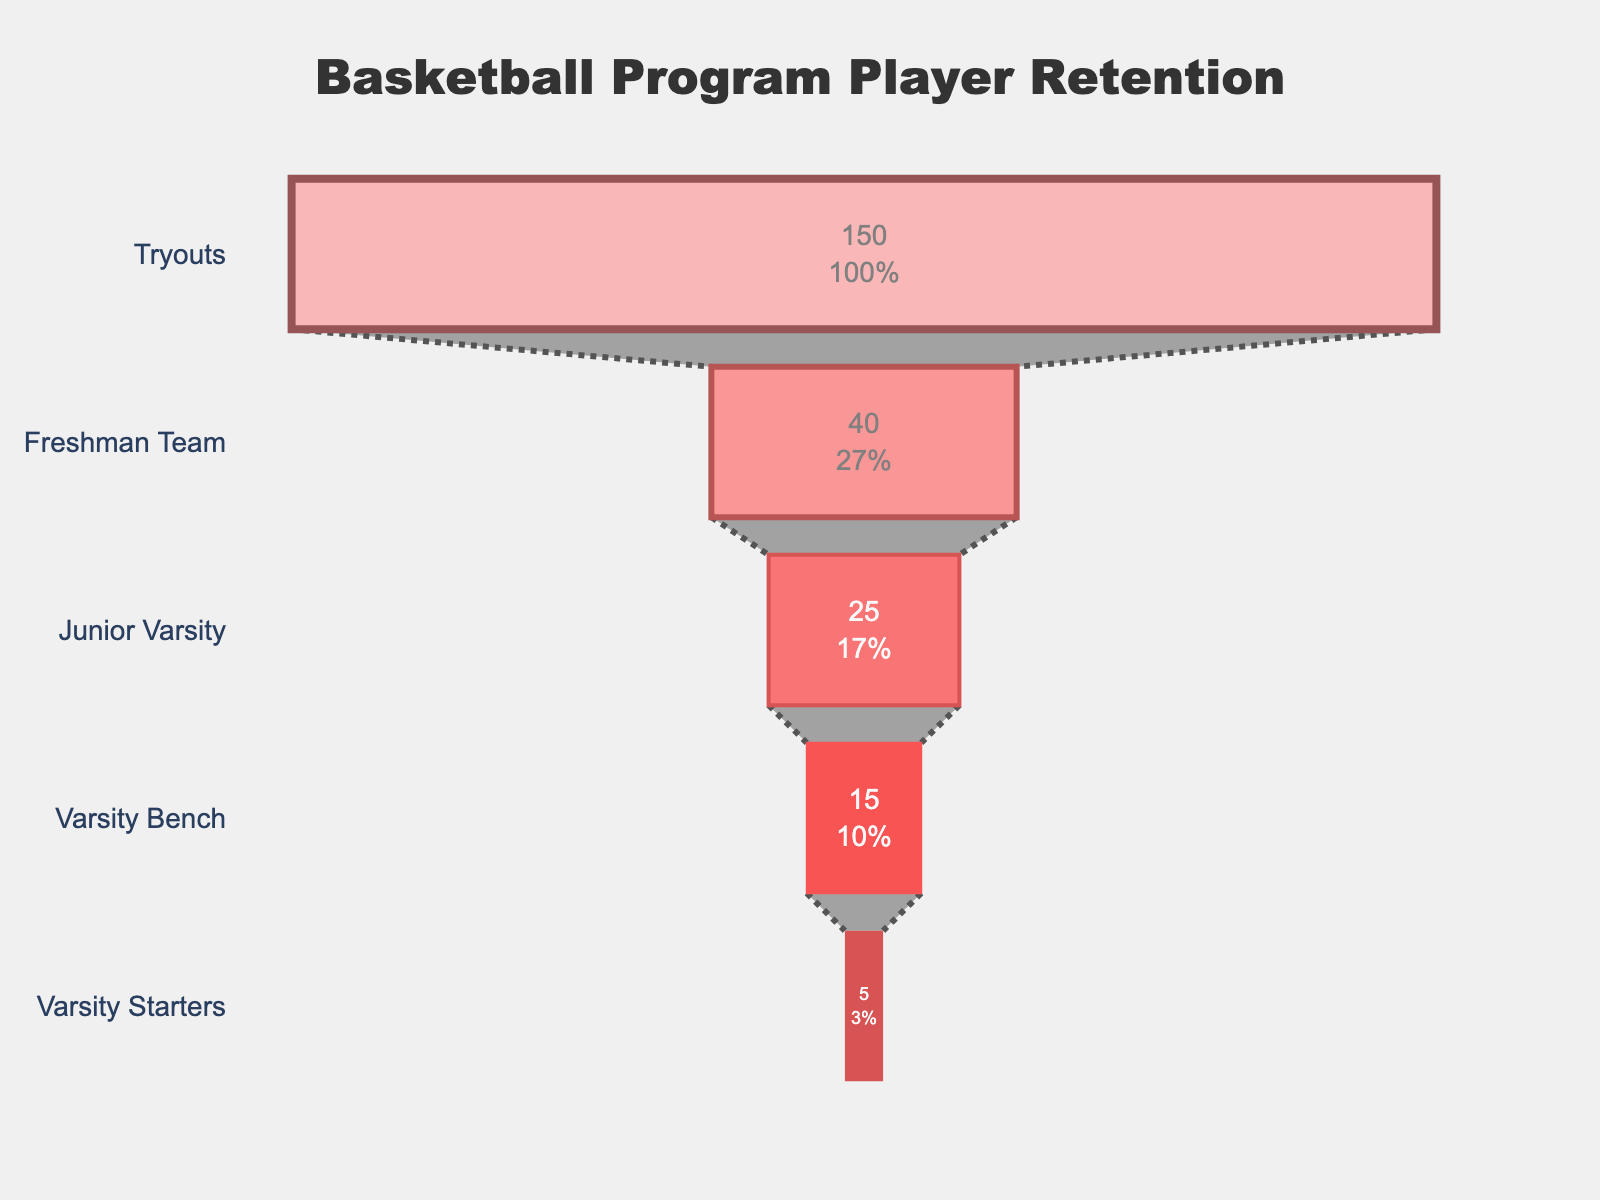What's the title of the chart? The title is usually displayed at the top of the chart. In this case, it states "Basketball Program Player Retention."
Answer: Basketball Program Player Retention How many players advanced to the Freshman Team stage? Each stage displays the number of players retained from the previous stage. For the Freshman Team, the figure shows 40 players.
Answer: 40 What percentage of players from tryouts make it to the varsity starters? The figure displays percentage values inside each section. To find the percentage from tryouts to varsity starters, divide 5 by 150 and multiply by 100. The figure shows this percentage as well.
Answer: 3.33% How many players drop out after the Freshman Team stage? The number of players at Freshman Team is 40 and at Junior Varsity is 25. The difference, 40 - 25, gives the number who drop out.
Answer: 15 Which stage has the steepest drop in player numbers? By comparing the differences between each consecutive stage, the largest decrease is from Tryouts (150) to Freshman Team (40). The difference is 110, making it the steepest drop.
Answer: Tryouts to Freshman Team How many players make it to the Varsity Starters stage? This number is displayed for the Varsity Starters directly in the chart.
Answer: 5 What is the ratio of players from the Junior Varsity team to the Varsity Bench? By dividing the number of Junior Varsity players (25) by the Varsity Bench players (15), we get the ratio.
Answer: 5:3 What is the color gradient used in the funnel chart? The chart uses shades of red that get darker as the stages progress from Tryouts to Varsity Starters. Described as light red to dark red in color.
Answer: Shades of red What percentage of players move from the Varsity Bench to the Varsity Starters? To find this, divide the number of Varsity Starters (5) by the number of Varsity Bench players (15) and multiply by 100.
Answer: 33.33% What's the difference in the retention rate from Freshman Team to Junior Varsity compared to Tryouts to Freshman Team? Calculate the percentages for both stages: (25/40)*100 = 62.5% and (40/150)*100 = 26.67%. The difference is 62.5% - 26.67%.
Answer: 35.83% 